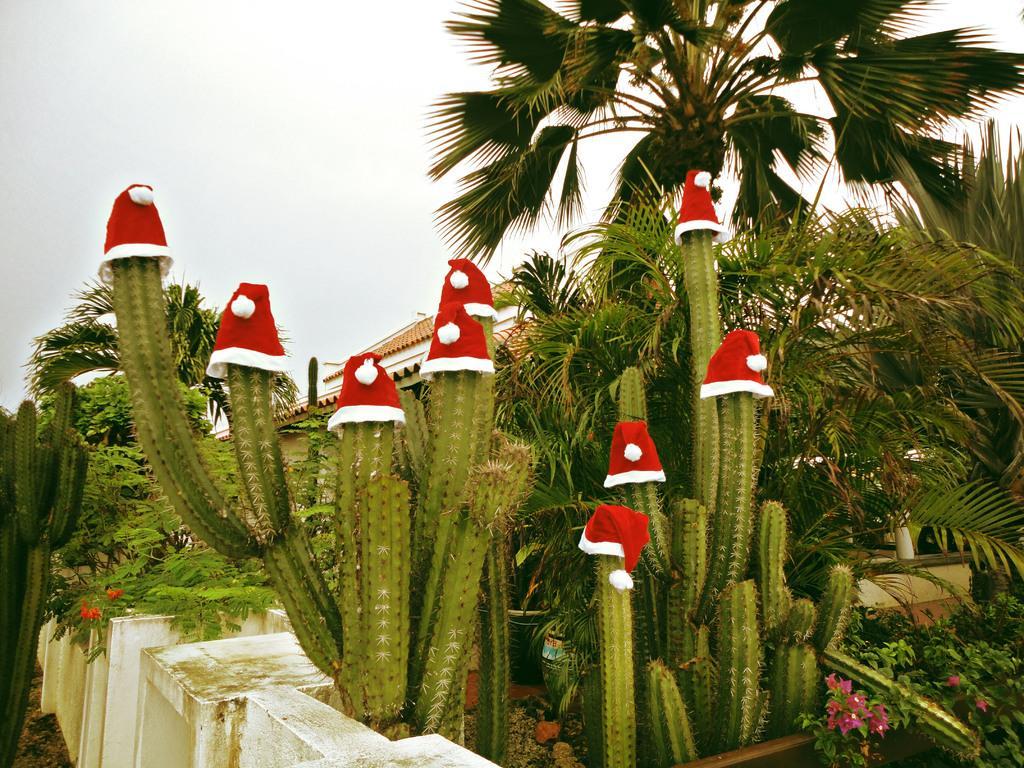Can you describe this image briefly? In this image I can see number of plants, flowers, few trees and in the front I can see number of red and white colour caps on few plants. In the background I can see a building and the sky. 